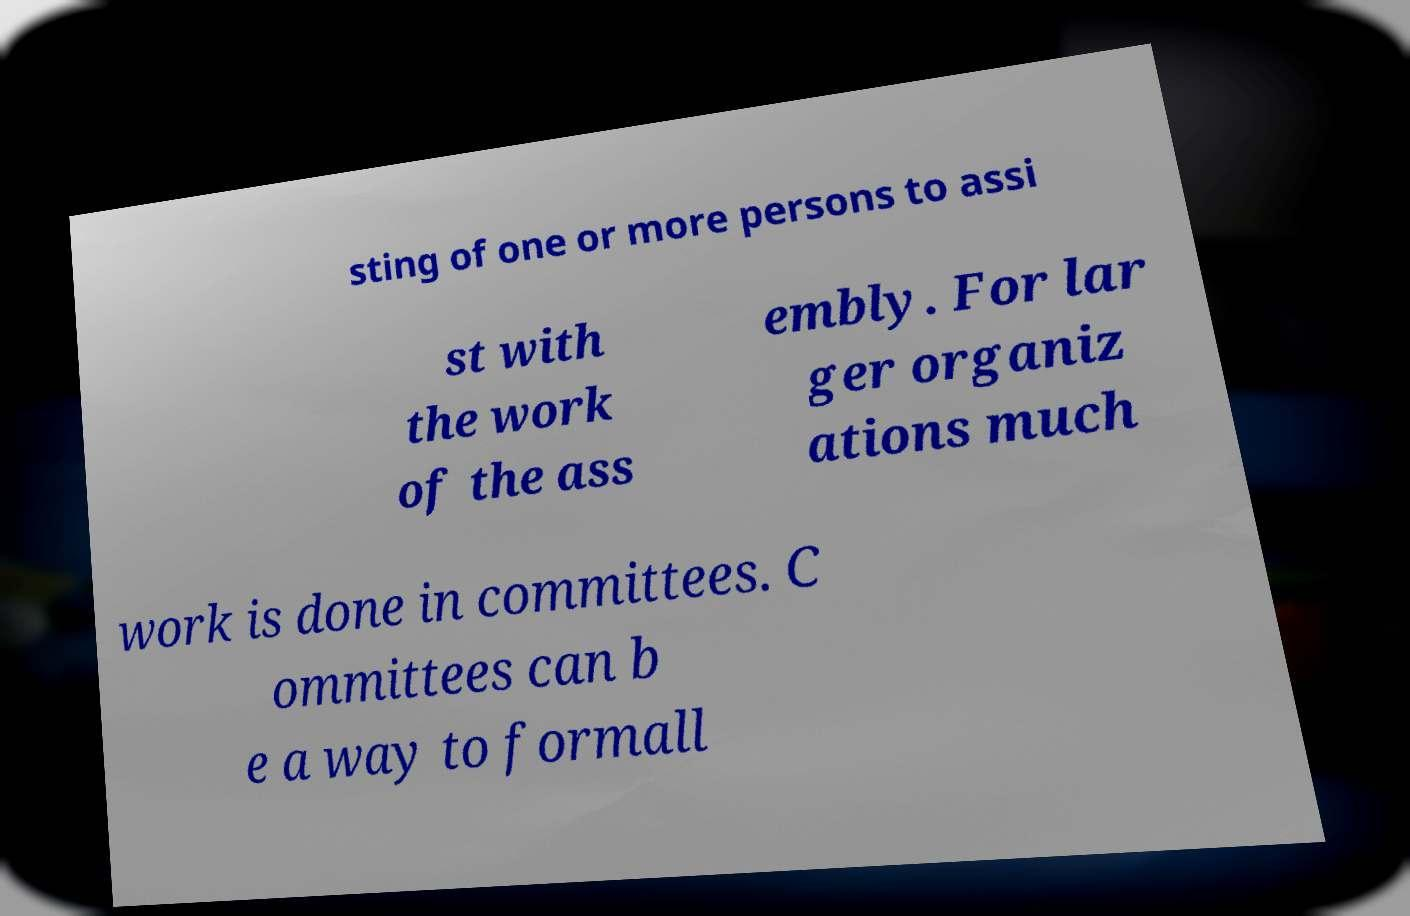I need the written content from this picture converted into text. Can you do that? sting of one or more persons to assi st with the work of the ass embly. For lar ger organiz ations much work is done in committees. C ommittees can b e a way to formall 